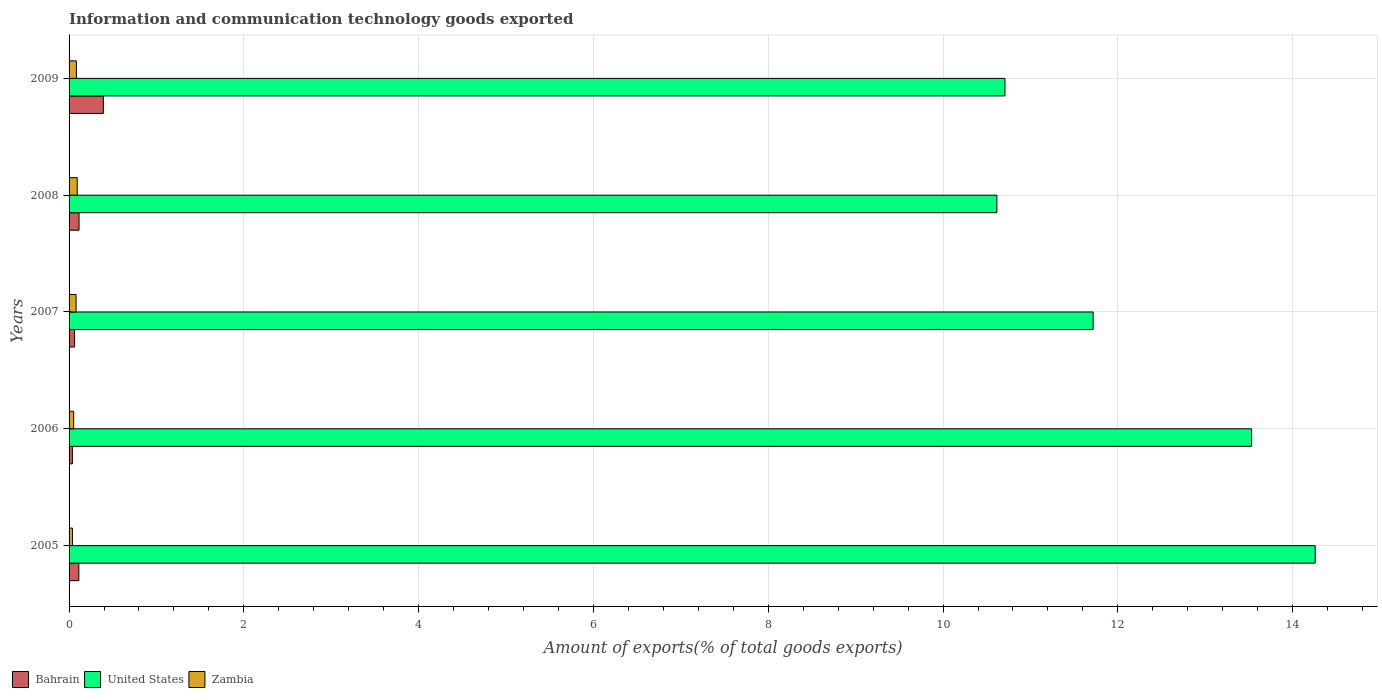How many groups of bars are there?
Make the answer very short. 5. In how many cases, is the number of bars for a given year not equal to the number of legend labels?
Your answer should be compact. 0. What is the amount of goods exported in United States in 2005?
Give a very brief answer. 14.26. Across all years, what is the maximum amount of goods exported in Bahrain?
Ensure brevity in your answer.  0.39. Across all years, what is the minimum amount of goods exported in Zambia?
Offer a very short reply. 0.04. In which year was the amount of goods exported in Bahrain minimum?
Keep it short and to the point. 2006. What is the total amount of goods exported in United States in the graph?
Your response must be concise. 60.83. What is the difference between the amount of goods exported in United States in 2006 and that in 2007?
Offer a very short reply. 1.81. What is the difference between the amount of goods exported in Bahrain in 2005 and the amount of goods exported in United States in 2008?
Your answer should be very brief. -10.5. What is the average amount of goods exported in United States per year?
Your answer should be very brief. 12.17. In the year 2006, what is the difference between the amount of goods exported in Bahrain and amount of goods exported in Zambia?
Offer a very short reply. -0.01. What is the ratio of the amount of goods exported in Zambia in 2006 to that in 2008?
Give a very brief answer. 0.56. Is the difference between the amount of goods exported in Bahrain in 2005 and 2006 greater than the difference between the amount of goods exported in Zambia in 2005 and 2006?
Give a very brief answer. Yes. What is the difference between the highest and the second highest amount of goods exported in Bahrain?
Your answer should be very brief. 0.28. What is the difference between the highest and the lowest amount of goods exported in United States?
Your response must be concise. 3.64. Is the sum of the amount of goods exported in Bahrain in 2005 and 2009 greater than the maximum amount of goods exported in Zambia across all years?
Provide a short and direct response. Yes. What does the 3rd bar from the top in 2008 represents?
Keep it short and to the point. Bahrain. How many bars are there?
Keep it short and to the point. 15. What is the difference between two consecutive major ticks on the X-axis?
Your answer should be compact. 2. Does the graph contain any zero values?
Provide a succinct answer. No. How are the legend labels stacked?
Make the answer very short. Horizontal. What is the title of the graph?
Keep it short and to the point. Information and communication technology goods exported. What is the label or title of the X-axis?
Ensure brevity in your answer.  Amount of exports(% of total goods exports). What is the label or title of the Y-axis?
Offer a very short reply. Years. What is the Amount of exports(% of total goods exports) of Bahrain in 2005?
Offer a terse response. 0.11. What is the Amount of exports(% of total goods exports) of United States in 2005?
Your response must be concise. 14.26. What is the Amount of exports(% of total goods exports) of Zambia in 2005?
Provide a short and direct response. 0.04. What is the Amount of exports(% of total goods exports) of Bahrain in 2006?
Offer a terse response. 0.04. What is the Amount of exports(% of total goods exports) in United States in 2006?
Offer a very short reply. 13.53. What is the Amount of exports(% of total goods exports) in Zambia in 2006?
Provide a short and direct response. 0.05. What is the Amount of exports(% of total goods exports) in Bahrain in 2007?
Your response must be concise. 0.06. What is the Amount of exports(% of total goods exports) in United States in 2007?
Provide a short and direct response. 11.72. What is the Amount of exports(% of total goods exports) of Zambia in 2007?
Your response must be concise. 0.08. What is the Amount of exports(% of total goods exports) of Bahrain in 2008?
Keep it short and to the point. 0.11. What is the Amount of exports(% of total goods exports) in United States in 2008?
Provide a short and direct response. 10.62. What is the Amount of exports(% of total goods exports) in Zambia in 2008?
Make the answer very short. 0.09. What is the Amount of exports(% of total goods exports) of Bahrain in 2009?
Provide a succinct answer. 0.39. What is the Amount of exports(% of total goods exports) in United States in 2009?
Your answer should be very brief. 10.71. What is the Amount of exports(% of total goods exports) in Zambia in 2009?
Your response must be concise. 0.08. Across all years, what is the maximum Amount of exports(% of total goods exports) of Bahrain?
Your answer should be very brief. 0.39. Across all years, what is the maximum Amount of exports(% of total goods exports) in United States?
Your response must be concise. 14.26. Across all years, what is the maximum Amount of exports(% of total goods exports) in Zambia?
Offer a very short reply. 0.09. Across all years, what is the minimum Amount of exports(% of total goods exports) in Bahrain?
Offer a terse response. 0.04. Across all years, what is the minimum Amount of exports(% of total goods exports) in United States?
Make the answer very short. 10.62. Across all years, what is the minimum Amount of exports(% of total goods exports) of Zambia?
Your answer should be compact. 0.04. What is the total Amount of exports(% of total goods exports) of Bahrain in the graph?
Make the answer very short. 0.72. What is the total Amount of exports(% of total goods exports) of United States in the graph?
Make the answer very short. 60.83. What is the total Amount of exports(% of total goods exports) of Zambia in the graph?
Keep it short and to the point. 0.35. What is the difference between the Amount of exports(% of total goods exports) in Bahrain in 2005 and that in 2006?
Give a very brief answer. 0.07. What is the difference between the Amount of exports(% of total goods exports) in United States in 2005 and that in 2006?
Ensure brevity in your answer.  0.73. What is the difference between the Amount of exports(% of total goods exports) in Zambia in 2005 and that in 2006?
Offer a terse response. -0.01. What is the difference between the Amount of exports(% of total goods exports) in Bahrain in 2005 and that in 2007?
Provide a succinct answer. 0.05. What is the difference between the Amount of exports(% of total goods exports) in United States in 2005 and that in 2007?
Ensure brevity in your answer.  2.54. What is the difference between the Amount of exports(% of total goods exports) of Zambia in 2005 and that in 2007?
Ensure brevity in your answer.  -0.04. What is the difference between the Amount of exports(% of total goods exports) of Bahrain in 2005 and that in 2008?
Make the answer very short. -0. What is the difference between the Amount of exports(% of total goods exports) in United States in 2005 and that in 2008?
Ensure brevity in your answer.  3.64. What is the difference between the Amount of exports(% of total goods exports) in Zambia in 2005 and that in 2008?
Offer a very short reply. -0.05. What is the difference between the Amount of exports(% of total goods exports) in Bahrain in 2005 and that in 2009?
Your response must be concise. -0.28. What is the difference between the Amount of exports(% of total goods exports) in United States in 2005 and that in 2009?
Offer a very short reply. 3.55. What is the difference between the Amount of exports(% of total goods exports) in Zambia in 2005 and that in 2009?
Ensure brevity in your answer.  -0.05. What is the difference between the Amount of exports(% of total goods exports) of Bahrain in 2006 and that in 2007?
Provide a short and direct response. -0.03. What is the difference between the Amount of exports(% of total goods exports) of United States in 2006 and that in 2007?
Provide a succinct answer. 1.81. What is the difference between the Amount of exports(% of total goods exports) in Zambia in 2006 and that in 2007?
Offer a very short reply. -0.03. What is the difference between the Amount of exports(% of total goods exports) of Bahrain in 2006 and that in 2008?
Offer a terse response. -0.08. What is the difference between the Amount of exports(% of total goods exports) of United States in 2006 and that in 2008?
Ensure brevity in your answer.  2.91. What is the difference between the Amount of exports(% of total goods exports) in Zambia in 2006 and that in 2008?
Provide a short and direct response. -0.04. What is the difference between the Amount of exports(% of total goods exports) of Bahrain in 2006 and that in 2009?
Ensure brevity in your answer.  -0.35. What is the difference between the Amount of exports(% of total goods exports) of United States in 2006 and that in 2009?
Make the answer very short. 2.82. What is the difference between the Amount of exports(% of total goods exports) in Zambia in 2006 and that in 2009?
Your response must be concise. -0.03. What is the difference between the Amount of exports(% of total goods exports) in Bahrain in 2007 and that in 2008?
Make the answer very short. -0.05. What is the difference between the Amount of exports(% of total goods exports) in United States in 2007 and that in 2008?
Your answer should be very brief. 1.1. What is the difference between the Amount of exports(% of total goods exports) in Zambia in 2007 and that in 2008?
Your answer should be very brief. -0.01. What is the difference between the Amount of exports(% of total goods exports) in Bahrain in 2007 and that in 2009?
Give a very brief answer. -0.33. What is the difference between the Amount of exports(% of total goods exports) in Zambia in 2007 and that in 2009?
Your answer should be compact. -0. What is the difference between the Amount of exports(% of total goods exports) in Bahrain in 2008 and that in 2009?
Your response must be concise. -0.28. What is the difference between the Amount of exports(% of total goods exports) of United States in 2008 and that in 2009?
Your answer should be compact. -0.09. What is the difference between the Amount of exports(% of total goods exports) in Zambia in 2008 and that in 2009?
Make the answer very short. 0.01. What is the difference between the Amount of exports(% of total goods exports) of Bahrain in 2005 and the Amount of exports(% of total goods exports) of United States in 2006?
Offer a terse response. -13.42. What is the difference between the Amount of exports(% of total goods exports) in Bahrain in 2005 and the Amount of exports(% of total goods exports) in Zambia in 2006?
Offer a very short reply. 0.06. What is the difference between the Amount of exports(% of total goods exports) in United States in 2005 and the Amount of exports(% of total goods exports) in Zambia in 2006?
Ensure brevity in your answer.  14.21. What is the difference between the Amount of exports(% of total goods exports) of Bahrain in 2005 and the Amount of exports(% of total goods exports) of United States in 2007?
Keep it short and to the point. -11.61. What is the difference between the Amount of exports(% of total goods exports) of Bahrain in 2005 and the Amount of exports(% of total goods exports) of Zambia in 2007?
Ensure brevity in your answer.  0.03. What is the difference between the Amount of exports(% of total goods exports) in United States in 2005 and the Amount of exports(% of total goods exports) in Zambia in 2007?
Your answer should be very brief. 14.18. What is the difference between the Amount of exports(% of total goods exports) in Bahrain in 2005 and the Amount of exports(% of total goods exports) in United States in 2008?
Offer a terse response. -10.5. What is the difference between the Amount of exports(% of total goods exports) in Bahrain in 2005 and the Amount of exports(% of total goods exports) in Zambia in 2008?
Your answer should be compact. 0.02. What is the difference between the Amount of exports(% of total goods exports) of United States in 2005 and the Amount of exports(% of total goods exports) of Zambia in 2008?
Provide a short and direct response. 14.16. What is the difference between the Amount of exports(% of total goods exports) in Bahrain in 2005 and the Amount of exports(% of total goods exports) in United States in 2009?
Give a very brief answer. -10.6. What is the difference between the Amount of exports(% of total goods exports) of Bahrain in 2005 and the Amount of exports(% of total goods exports) of Zambia in 2009?
Provide a succinct answer. 0.03. What is the difference between the Amount of exports(% of total goods exports) in United States in 2005 and the Amount of exports(% of total goods exports) in Zambia in 2009?
Keep it short and to the point. 14.17. What is the difference between the Amount of exports(% of total goods exports) of Bahrain in 2006 and the Amount of exports(% of total goods exports) of United States in 2007?
Ensure brevity in your answer.  -11.68. What is the difference between the Amount of exports(% of total goods exports) of Bahrain in 2006 and the Amount of exports(% of total goods exports) of Zambia in 2007?
Ensure brevity in your answer.  -0.04. What is the difference between the Amount of exports(% of total goods exports) of United States in 2006 and the Amount of exports(% of total goods exports) of Zambia in 2007?
Make the answer very short. 13.45. What is the difference between the Amount of exports(% of total goods exports) of Bahrain in 2006 and the Amount of exports(% of total goods exports) of United States in 2008?
Offer a terse response. -10.58. What is the difference between the Amount of exports(% of total goods exports) of Bahrain in 2006 and the Amount of exports(% of total goods exports) of Zambia in 2008?
Provide a succinct answer. -0.06. What is the difference between the Amount of exports(% of total goods exports) in United States in 2006 and the Amount of exports(% of total goods exports) in Zambia in 2008?
Your response must be concise. 13.44. What is the difference between the Amount of exports(% of total goods exports) in Bahrain in 2006 and the Amount of exports(% of total goods exports) in United States in 2009?
Make the answer very short. -10.67. What is the difference between the Amount of exports(% of total goods exports) in Bahrain in 2006 and the Amount of exports(% of total goods exports) in Zambia in 2009?
Provide a short and direct response. -0.05. What is the difference between the Amount of exports(% of total goods exports) of United States in 2006 and the Amount of exports(% of total goods exports) of Zambia in 2009?
Your answer should be compact. 13.45. What is the difference between the Amount of exports(% of total goods exports) in Bahrain in 2007 and the Amount of exports(% of total goods exports) in United States in 2008?
Your answer should be very brief. -10.55. What is the difference between the Amount of exports(% of total goods exports) in Bahrain in 2007 and the Amount of exports(% of total goods exports) in Zambia in 2008?
Your response must be concise. -0.03. What is the difference between the Amount of exports(% of total goods exports) in United States in 2007 and the Amount of exports(% of total goods exports) in Zambia in 2008?
Offer a very short reply. 11.62. What is the difference between the Amount of exports(% of total goods exports) of Bahrain in 2007 and the Amount of exports(% of total goods exports) of United States in 2009?
Offer a terse response. -10.65. What is the difference between the Amount of exports(% of total goods exports) of Bahrain in 2007 and the Amount of exports(% of total goods exports) of Zambia in 2009?
Give a very brief answer. -0.02. What is the difference between the Amount of exports(% of total goods exports) of United States in 2007 and the Amount of exports(% of total goods exports) of Zambia in 2009?
Make the answer very short. 11.63. What is the difference between the Amount of exports(% of total goods exports) of Bahrain in 2008 and the Amount of exports(% of total goods exports) of United States in 2009?
Ensure brevity in your answer.  -10.59. What is the difference between the Amount of exports(% of total goods exports) in United States in 2008 and the Amount of exports(% of total goods exports) in Zambia in 2009?
Provide a short and direct response. 10.53. What is the average Amount of exports(% of total goods exports) in Bahrain per year?
Your answer should be very brief. 0.14. What is the average Amount of exports(% of total goods exports) of United States per year?
Make the answer very short. 12.17. What is the average Amount of exports(% of total goods exports) of Zambia per year?
Make the answer very short. 0.07. In the year 2005, what is the difference between the Amount of exports(% of total goods exports) of Bahrain and Amount of exports(% of total goods exports) of United States?
Offer a terse response. -14.15. In the year 2005, what is the difference between the Amount of exports(% of total goods exports) in Bahrain and Amount of exports(% of total goods exports) in Zambia?
Provide a short and direct response. 0.07. In the year 2005, what is the difference between the Amount of exports(% of total goods exports) in United States and Amount of exports(% of total goods exports) in Zambia?
Provide a short and direct response. 14.22. In the year 2006, what is the difference between the Amount of exports(% of total goods exports) in Bahrain and Amount of exports(% of total goods exports) in United States?
Your response must be concise. -13.49. In the year 2006, what is the difference between the Amount of exports(% of total goods exports) of Bahrain and Amount of exports(% of total goods exports) of Zambia?
Make the answer very short. -0.01. In the year 2006, what is the difference between the Amount of exports(% of total goods exports) of United States and Amount of exports(% of total goods exports) of Zambia?
Provide a short and direct response. 13.48. In the year 2007, what is the difference between the Amount of exports(% of total goods exports) of Bahrain and Amount of exports(% of total goods exports) of United States?
Your answer should be compact. -11.65. In the year 2007, what is the difference between the Amount of exports(% of total goods exports) in Bahrain and Amount of exports(% of total goods exports) in Zambia?
Offer a terse response. -0.02. In the year 2007, what is the difference between the Amount of exports(% of total goods exports) in United States and Amount of exports(% of total goods exports) in Zambia?
Provide a short and direct response. 11.64. In the year 2008, what is the difference between the Amount of exports(% of total goods exports) of Bahrain and Amount of exports(% of total goods exports) of United States?
Give a very brief answer. -10.5. In the year 2008, what is the difference between the Amount of exports(% of total goods exports) of Bahrain and Amount of exports(% of total goods exports) of Zambia?
Your response must be concise. 0.02. In the year 2008, what is the difference between the Amount of exports(% of total goods exports) in United States and Amount of exports(% of total goods exports) in Zambia?
Your answer should be very brief. 10.52. In the year 2009, what is the difference between the Amount of exports(% of total goods exports) of Bahrain and Amount of exports(% of total goods exports) of United States?
Provide a short and direct response. -10.32. In the year 2009, what is the difference between the Amount of exports(% of total goods exports) of Bahrain and Amount of exports(% of total goods exports) of Zambia?
Your response must be concise. 0.31. In the year 2009, what is the difference between the Amount of exports(% of total goods exports) in United States and Amount of exports(% of total goods exports) in Zambia?
Make the answer very short. 10.62. What is the ratio of the Amount of exports(% of total goods exports) in Bahrain in 2005 to that in 2006?
Your answer should be compact. 2.94. What is the ratio of the Amount of exports(% of total goods exports) in United States in 2005 to that in 2006?
Provide a short and direct response. 1.05. What is the ratio of the Amount of exports(% of total goods exports) in Zambia in 2005 to that in 2006?
Give a very brief answer. 0.74. What is the ratio of the Amount of exports(% of total goods exports) in Bahrain in 2005 to that in 2007?
Provide a succinct answer. 1.77. What is the ratio of the Amount of exports(% of total goods exports) of United States in 2005 to that in 2007?
Offer a very short reply. 1.22. What is the ratio of the Amount of exports(% of total goods exports) in Zambia in 2005 to that in 2007?
Your response must be concise. 0.49. What is the ratio of the Amount of exports(% of total goods exports) in Bahrain in 2005 to that in 2008?
Give a very brief answer. 0.98. What is the ratio of the Amount of exports(% of total goods exports) of United States in 2005 to that in 2008?
Provide a succinct answer. 1.34. What is the ratio of the Amount of exports(% of total goods exports) of Zambia in 2005 to that in 2008?
Your response must be concise. 0.42. What is the ratio of the Amount of exports(% of total goods exports) of Bahrain in 2005 to that in 2009?
Give a very brief answer. 0.28. What is the ratio of the Amount of exports(% of total goods exports) in United States in 2005 to that in 2009?
Your answer should be very brief. 1.33. What is the ratio of the Amount of exports(% of total goods exports) of Zambia in 2005 to that in 2009?
Make the answer very short. 0.46. What is the ratio of the Amount of exports(% of total goods exports) in Bahrain in 2006 to that in 2007?
Offer a very short reply. 0.6. What is the ratio of the Amount of exports(% of total goods exports) of United States in 2006 to that in 2007?
Ensure brevity in your answer.  1.15. What is the ratio of the Amount of exports(% of total goods exports) in Zambia in 2006 to that in 2007?
Make the answer very short. 0.66. What is the ratio of the Amount of exports(% of total goods exports) in Bahrain in 2006 to that in 2008?
Provide a succinct answer. 0.33. What is the ratio of the Amount of exports(% of total goods exports) in United States in 2006 to that in 2008?
Give a very brief answer. 1.27. What is the ratio of the Amount of exports(% of total goods exports) in Zambia in 2006 to that in 2008?
Ensure brevity in your answer.  0.56. What is the ratio of the Amount of exports(% of total goods exports) of Bahrain in 2006 to that in 2009?
Give a very brief answer. 0.1. What is the ratio of the Amount of exports(% of total goods exports) in United States in 2006 to that in 2009?
Your answer should be very brief. 1.26. What is the ratio of the Amount of exports(% of total goods exports) in Zambia in 2006 to that in 2009?
Provide a succinct answer. 0.63. What is the ratio of the Amount of exports(% of total goods exports) in Bahrain in 2007 to that in 2008?
Give a very brief answer. 0.55. What is the ratio of the Amount of exports(% of total goods exports) in United States in 2007 to that in 2008?
Your answer should be compact. 1.1. What is the ratio of the Amount of exports(% of total goods exports) in Zambia in 2007 to that in 2008?
Your answer should be compact. 0.86. What is the ratio of the Amount of exports(% of total goods exports) in Bahrain in 2007 to that in 2009?
Offer a terse response. 0.16. What is the ratio of the Amount of exports(% of total goods exports) of United States in 2007 to that in 2009?
Your answer should be very brief. 1.09. What is the ratio of the Amount of exports(% of total goods exports) of Zambia in 2007 to that in 2009?
Keep it short and to the point. 0.95. What is the ratio of the Amount of exports(% of total goods exports) in Bahrain in 2008 to that in 2009?
Provide a short and direct response. 0.29. What is the ratio of the Amount of exports(% of total goods exports) in Zambia in 2008 to that in 2009?
Give a very brief answer. 1.11. What is the difference between the highest and the second highest Amount of exports(% of total goods exports) of Bahrain?
Provide a succinct answer. 0.28. What is the difference between the highest and the second highest Amount of exports(% of total goods exports) in United States?
Provide a short and direct response. 0.73. What is the difference between the highest and the second highest Amount of exports(% of total goods exports) of Zambia?
Your response must be concise. 0.01. What is the difference between the highest and the lowest Amount of exports(% of total goods exports) in Bahrain?
Give a very brief answer. 0.35. What is the difference between the highest and the lowest Amount of exports(% of total goods exports) of United States?
Ensure brevity in your answer.  3.64. What is the difference between the highest and the lowest Amount of exports(% of total goods exports) of Zambia?
Ensure brevity in your answer.  0.05. 